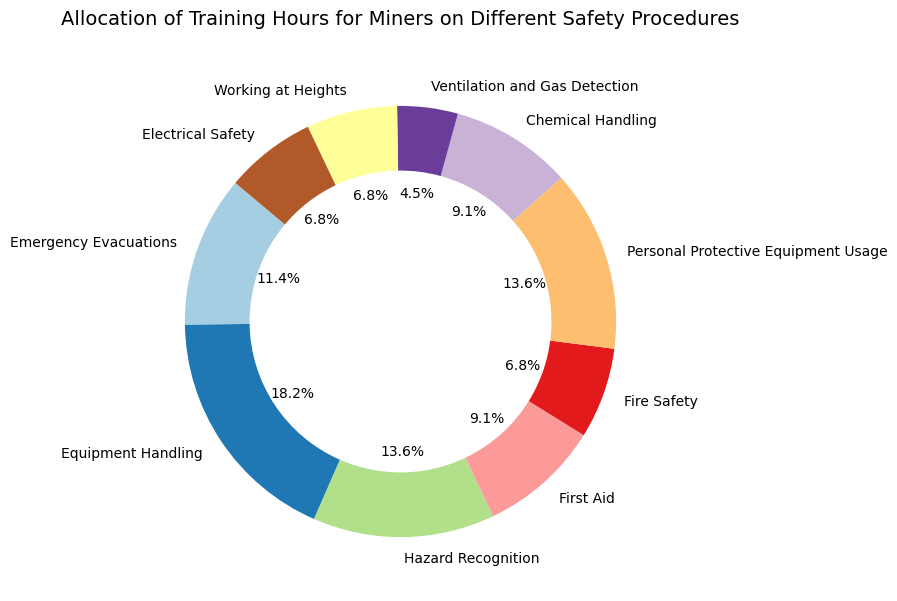What percentage of training hours is dedicated to Equipment Handling? Refer to the slice labeled 'Equipment Handling' on the pie chart and check the percentage shown. It is labeled as 28.6%.
Answer: 28.6% Which two safety procedures receive the same amount of training hours? Look at the pie chart slices and locate the labels with the same size (hours) and percentage. Both 'First Aid' and 'Chemical Handling' receive the same amount of training hours, which is 20 hours each.
Answer: First Aid and Chemical Handling What is the combined percentage of training hours for Hazard Recognition and Personal Protective Equipment Usage? Check the percentages shown on the pie chart for 'Hazard Recognition' and 'Personal Protective Equipment Usage.' 'Hazard Recognition' is 21.4% and 'Personal Protective Equipment Usage' is also 21.4%. Adding these together gives 42.8%.
Answer: 42.8% How many training hours are allocated to Ventilation and Gas Detection? Locate the slice labeled 'Ventilation and Gas Detection' on the pie chart. It shows 10 training hours, and this is 7.1% of the total shown in the chart.
Answer: 10 Are more training hours allocated to Electrical Safety or Fire Safety? Compare the two slices labeled 'Electrical Safety' and 'Fire Safety' in terms of their sizes and percentages on the pie chart. 'Electrical Safety' is allocated 15 hours and 10.7%, while 'Fire Safety' is also allocated 15 hours but labeled the same percentage.
Answer: Both have equal hours, 15 Which safety procedure has the smallest allocation of training hours? Identify the smallest slice on the pie chart to find the safety procedure with the least hours. 'Ventilation and Gas Detection' is the smallest, with 10 hours.
Answer: Ventilation and Gas Detection What is the total number of training hours allocated for Emergency Evacuations and First Aid? Find the training hours for 'Emergency Evacuations' and 'First Aid' from the pie chart. 'Emergency Evacuations' has 25 hours, and 'First Aid' has 20 hours. Adding them together gives 45 hours.
Answer: 45 Which category has more allocated hours: Working at Heights or Fire Safety? Compare the slices for 'Working at Heights' and 'Fire Safety' on the pie chart. Both categories are allocated 15 hours each, both representing 10.7%.
Answer: Both have equal hours, 15 How many more training hours are allocated for Equipment Handling compared to Emergency Evacuations? Subtract the training hours for 'Emergency Evacuations' (25 hours) from those for 'Equipment Handling' (40 hours). The difference is 15 hours.
Answer: 15 What is the sum of training hours for the safety procedures with less than 20 hours each? Find all the safety procedures with less than 20 hours: 'Fire Safety' (15 hours), 'Ventilation and Gas Detection' (10 hours), 'Working at Heights' (15 hours), 'Electrical Safety' (15 hours). Add these together: 15 + 10 + 15 + 15 = 55 hours.
Answer: 55 